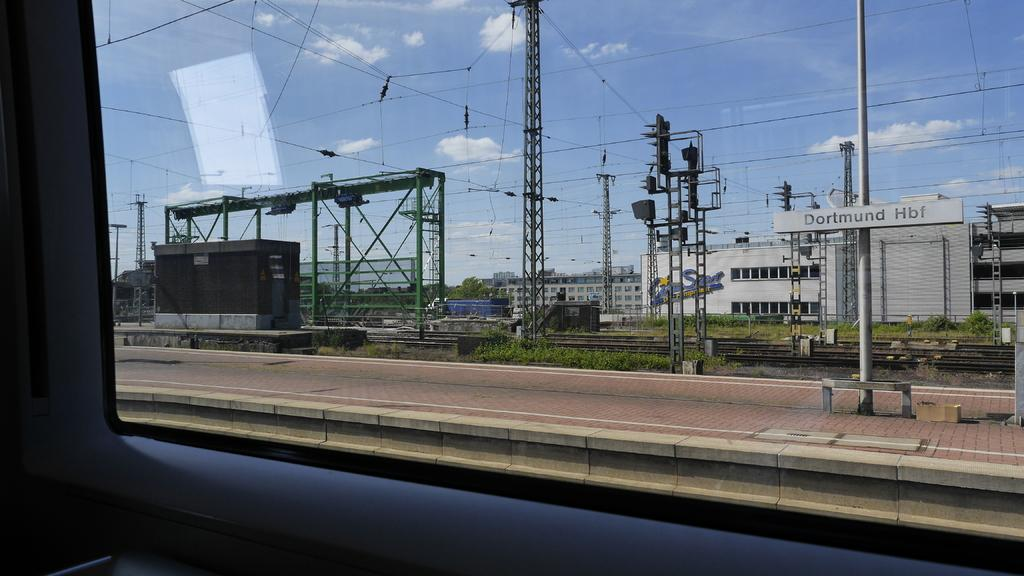What is the main subject of the image? The main subject of the image is a railway platform. What can be seen in the middle of the image? There are wires in the middle of the image. What is visible in the background of the image? There are buildings and clouds in the sky in the background of the image. How does the mother interact with the railway platform in the image? There is no mother present in the image, so it is not possible to answer that question. 